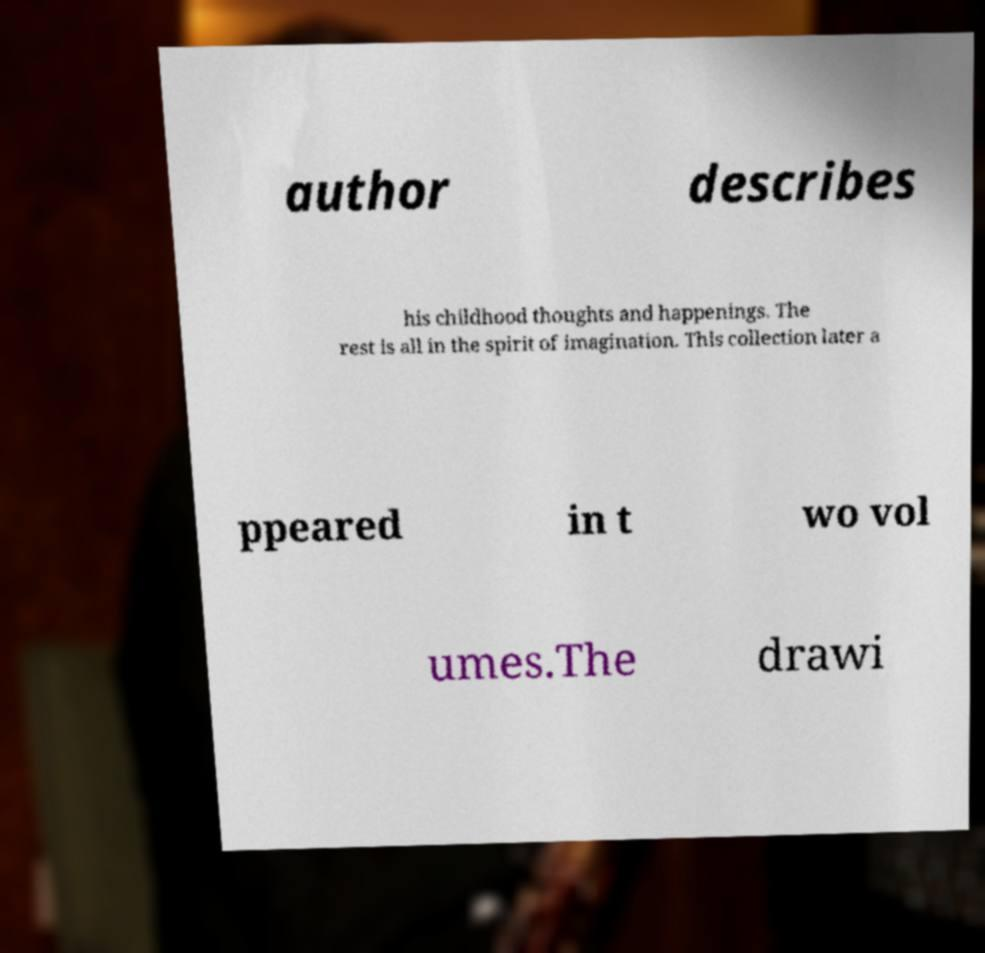There's text embedded in this image that I need extracted. Can you transcribe it verbatim? author describes his childhood thoughts and happenings. The rest is all in the spirit of imagination. This collection later a ppeared in t wo vol umes.The drawi 